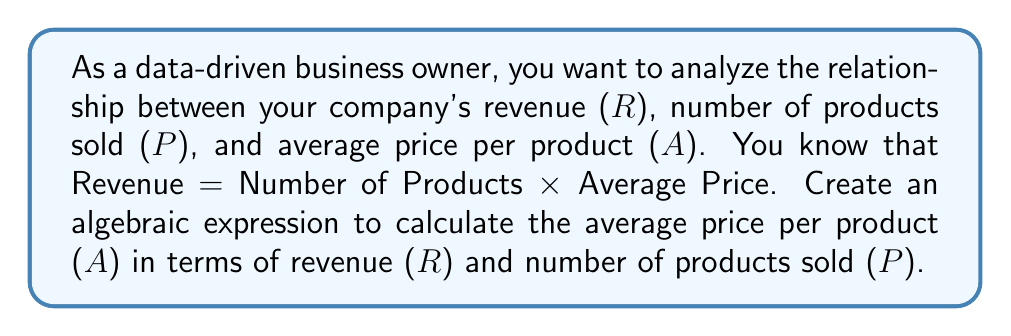Show me your answer to this math problem. Let's approach this step-by-step:

1. We start with the given relationship:
   Revenue = Number of Products × Average Price
   
2. We can represent this using variables:
   $R = P \times A$

3. To isolate A (Average Price), we need to divide both sides by P:
   $$\frac{R}{P} = \frac{P \times A}{P}$$

4. The P's on the right side cancel out:
   $$\frac{R}{P} = A$$

5. Therefore, we can express A in terms of R and P:
   $$A = \frac{R}{P}$$

This formula allows us to calculate the average price per product using the total revenue and the number of products sold, which is useful for data analysis in a business context.
Answer: $A = \frac{R}{P}$ 